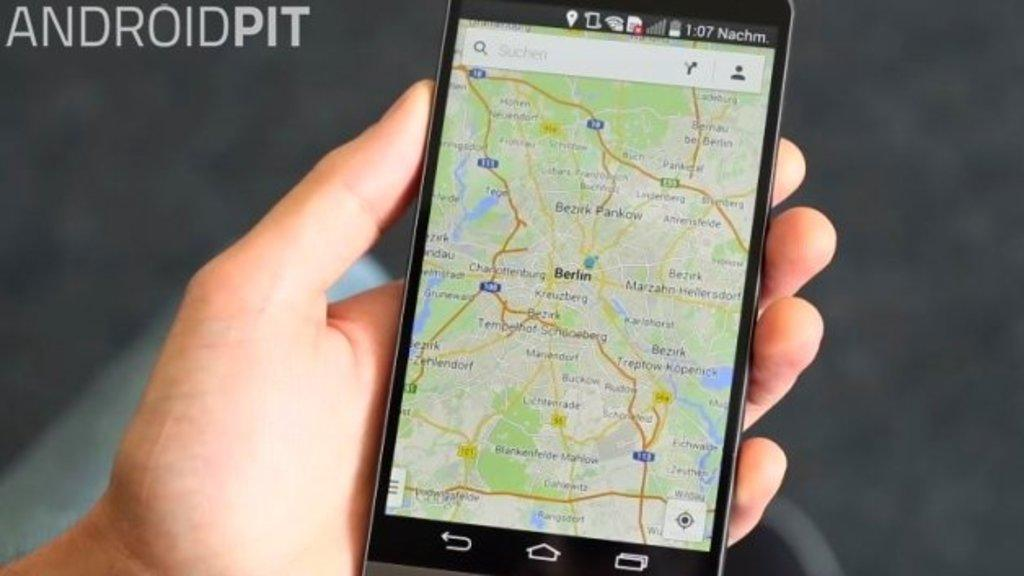<image>
Present a compact description of the photo's key features. Person holding a phone that says the time is 1:07. 